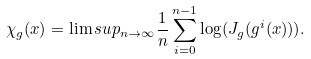Convert formula to latex. <formula><loc_0><loc_0><loc_500><loc_500>\chi _ { g } ( x ) = \lim s u p _ { n \to \infty } \frac { 1 } { n } \sum _ { i = 0 } ^ { n - 1 } \log ( J _ { g } ( g ^ { i } ( x ) ) ) .</formula> 